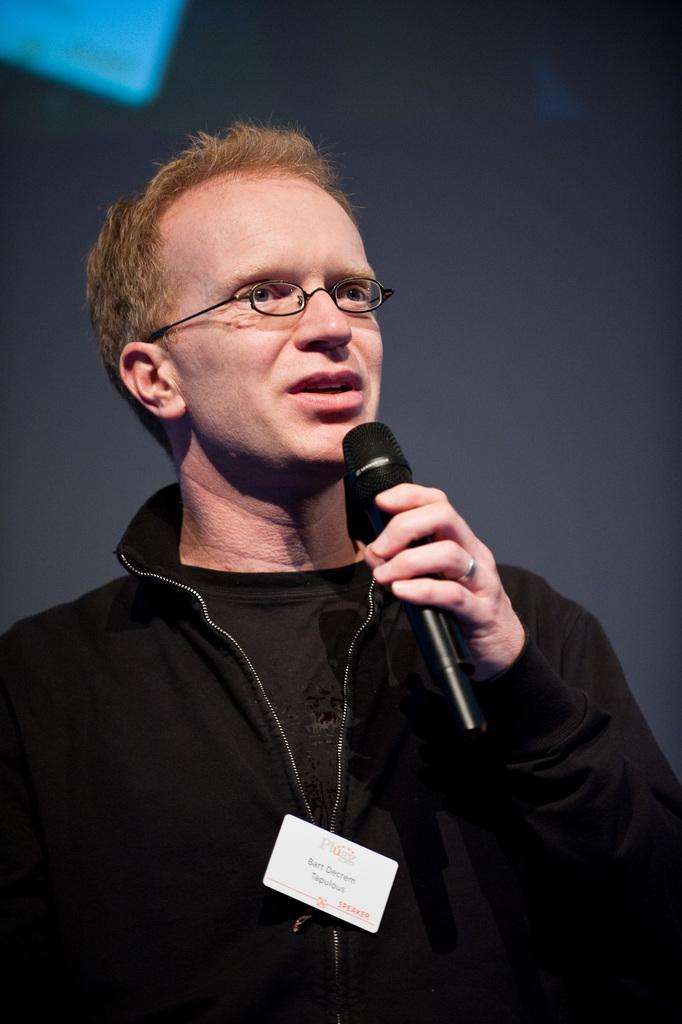Who is present in the image? There is a man in the image. What is the man holding in his hand? The man is holding a microphone (mike) in his hand. Is the woman holding an umbrella in the image? There is no woman present in the image, and therefore no umbrella can be observed. 